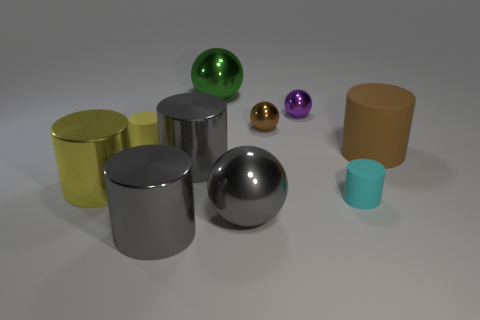The other small thing that is the same shape as the tiny purple thing is what color?
Make the answer very short. Brown. The other tiny ball that is the same material as the purple sphere is what color?
Make the answer very short. Brown. What number of metallic cylinders are the same size as the purple sphere?
Make the answer very short. 0. What is the big brown object made of?
Your response must be concise. Rubber. Is the number of tiny brown matte cylinders greater than the number of large brown objects?
Provide a short and direct response. No. Does the tiny purple shiny thing have the same shape as the big yellow thing?
Your answer should be compact. No. Is there any other thing that is the same shape as the tiny brown object?
Give a very brief answer. Yes. Do the small thing behind the brown shiny object and the small rubber thing that is left of the cyan matte cylinder have the same color?
Keep it short and to the point. No. Is the number of small shiny objects that are in front of the yellow matte thing less than the number of purple spheres that are on the left side of the big brown rubber cylinder?
Provide a short and direct response. Yes. What shape is the large metal object behind the tiny brown shiny thing?
Offer a terse response. Sphere. 